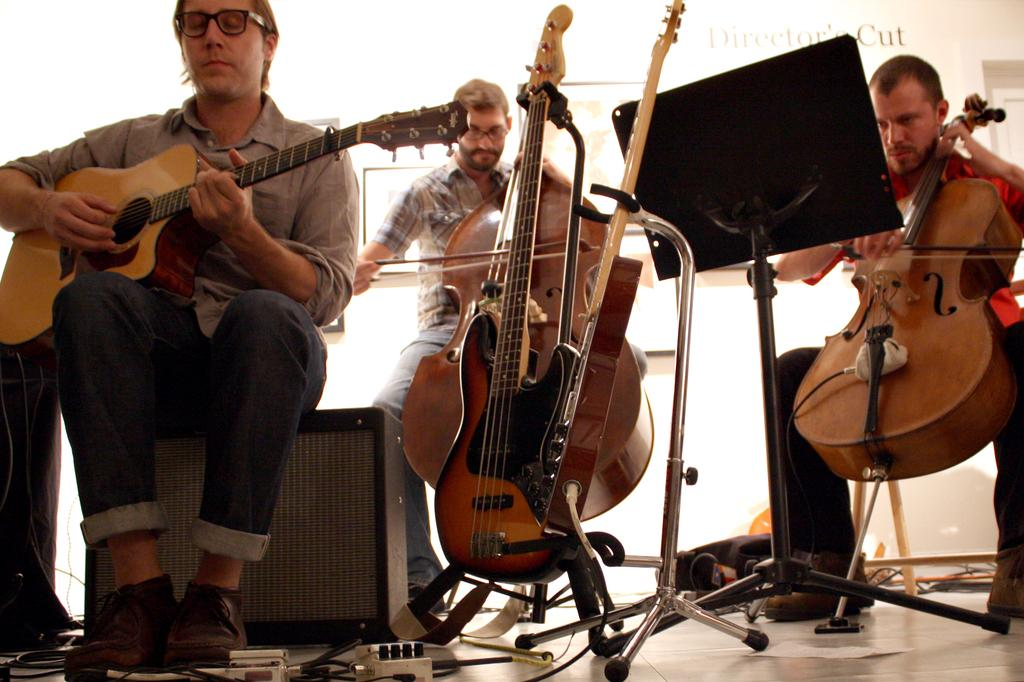How many people are present in the image? There are three people in the image. What are the people doing in the image? The people are playing musical instruments. Can you describe any additional objects in the image? Yes, there is a book stand in front of one of the people. What type of bead is being used as a guitar pick in the image? There is no bead or guitar present in the image, so it cannot be determined if a bead is being used as a guitar pick. 